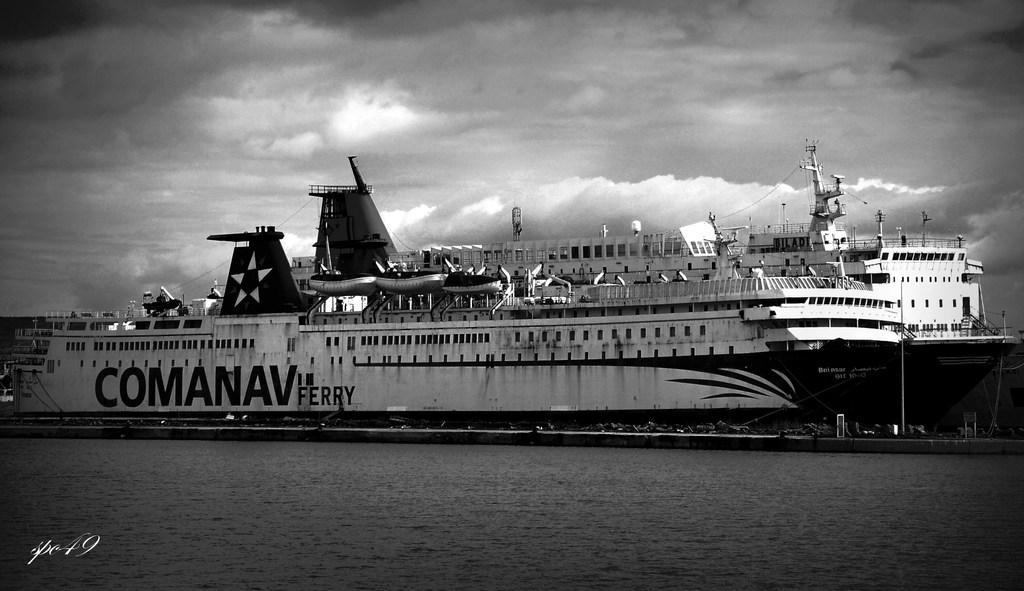<image>
Present a compact description of the photo's key features. A large Comanav fairy ship uncomfortably close to a Biladi ship. 